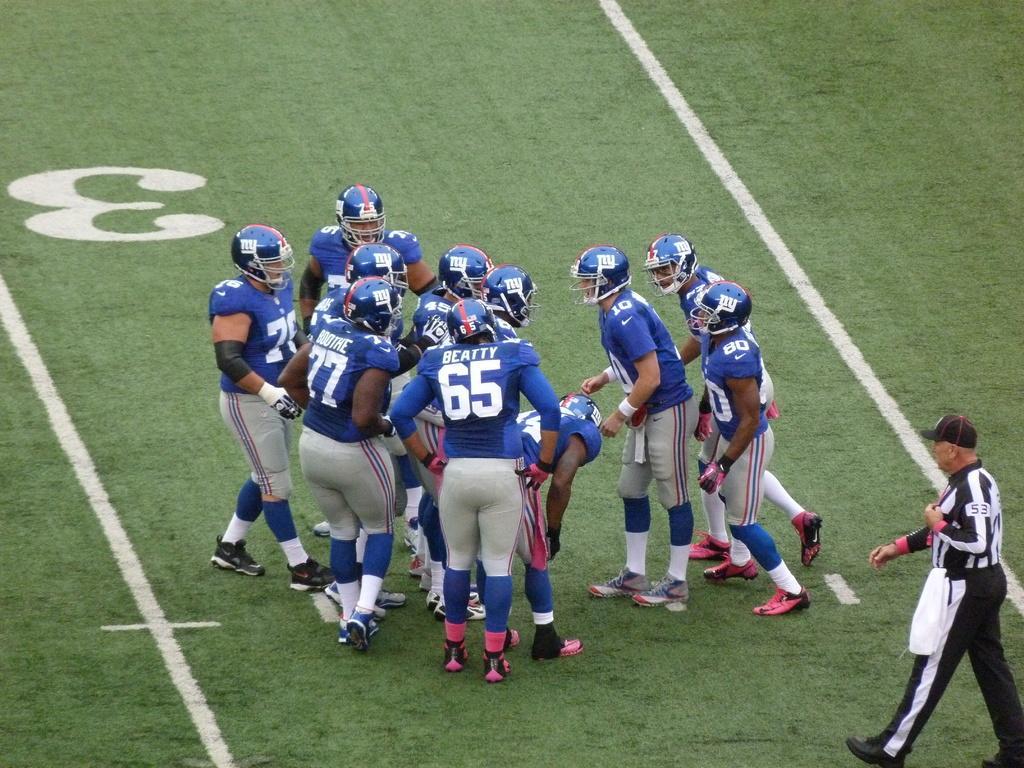Describe this image in one or two sentences. In this image I can see there are few persons wearing helmets visible on ground and I can see a person wearing a blue color dress walking towards ground on the right side. 